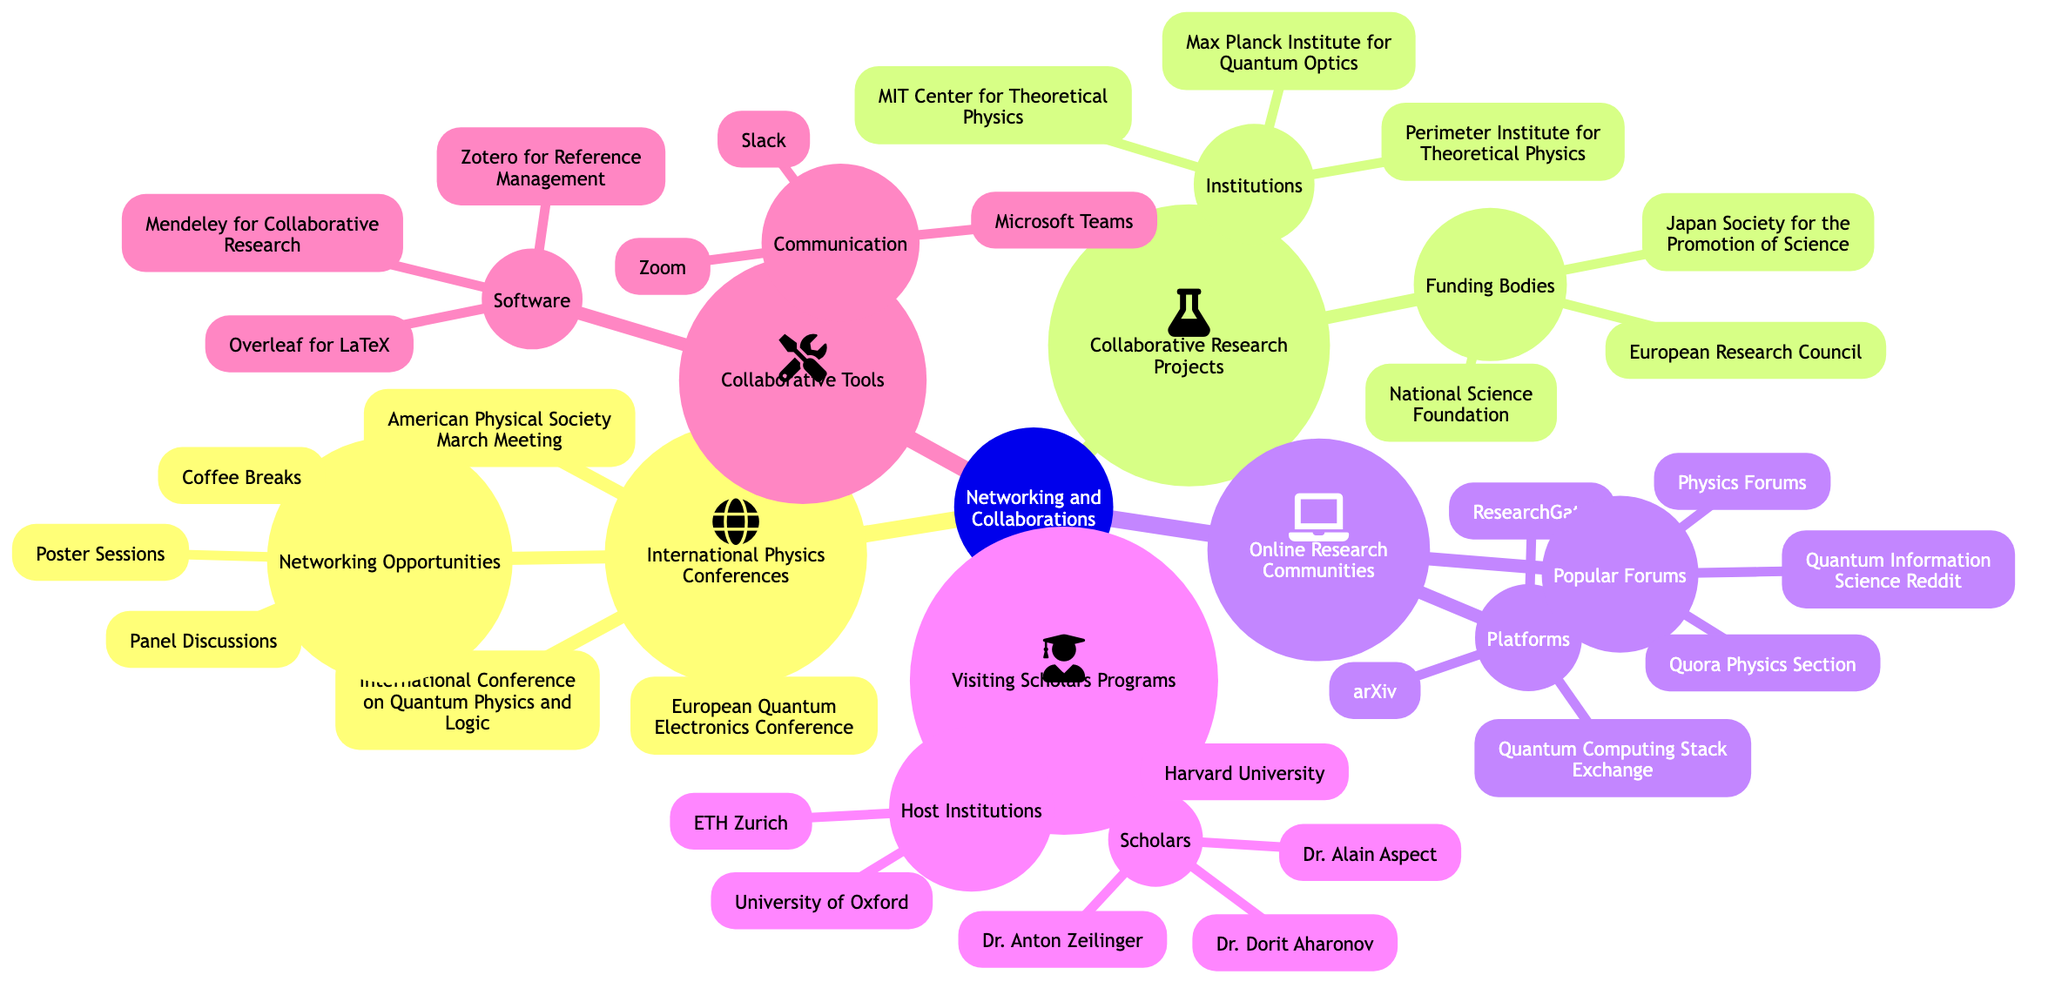What are the three international physics conferences listed? The diagram explicitly lists three conferences under "International Physics Conferences," which are "American Physical Society March Meeting," "European Quantum Electronics Conference," and "International Conference on Quantum Physics and Logic."
Answer: American Physical Society March Meeting, European Quantum Electronics Conference, International Conference on Quantum Physics and Logic How many institutions are involved in collaborative research projects? In the "Collaborative Research Projects" node, there are three specific institutions listed: "MIT Center for Theoretical Physics," "Max Planck Institute for Quantum Optics," and "Perimeter Institute for Theoretical Physics."
Answer: 3 Which funding body is associated with collaborative research projects? The "Funding Bodies" subsection under "Collaborative Research Projects" lists three specific organizations: "National Science Foundation," "European Research Council," and "Japan Society for the Promotion of Science." Therefore, any of these three could be the answer.
Answer: National Science Foundation, European Research Council, Japan Society for the Promotion of Science What is a popular forum for online research communities? Under "Online Research Communities," the section “Popular Forums” lists three forums: "Physics Forums," "Quantum Information Science Reddit," and "Quora Physics Section." Any of these could be deemed valid for the answer.
Answer: Physics Forums, Quantum Information Science Reddit, Quora Physics Section Who are the scholars mentioned in the visiting scholars programs? The “Visiting Scholars Programs” node lists three scholars: "Dr. Alain Aspect," "Dr. Dorit Aharonov," and "Dr. Anton Zeilinger." Each of these names can be independently stated as part of the answer.
Answer: Dr. Alain Aspect, Dr. Dorit Aharonov, Dr. Anton Zeilinger What software tools are listed for collaborative tools? The “Software” subsection under "Collaborative Tools" mentions three tools: "Overleaf for LaTeX," "Zotero for Reference Management," and "Mendeley for Collaborative Research." Any of these could serve as a valid answer.
Answer: Overleaf for LaTeX, Zotero for Reference Management, Mendeley for Collaborative Research Which communication tool is listed for collaborations? The "Communication" section under "Collaborative Tools" specifically mentions "Slack," "Zoom," and "Microsoft Teams," all of which are recognized tools for collaboration. Any of these qualifies as an answer.
Answer: Slack, Zoom, Microsoft Teams Which program would require hosting institutions? The "Visiting Scholars Programs" section denotes scholars who need hosting from institutions such as "Harvard University," "University of Oxford," and "ETH Zurich." Thus, this program is associated with hosting institutions.
Answer: Visiting Scholars Programs What type of opportunities are available at international conferences? Under the "Networking Opportunities" node, various opportunities are outlined, including "Panel Discussions," "Poster Sessions," and "Coffee Breaks." Any one of these would accurately reflect available opportunities.
Answer: Panel Discussions, Poster Sessions, Coffee Breaks 